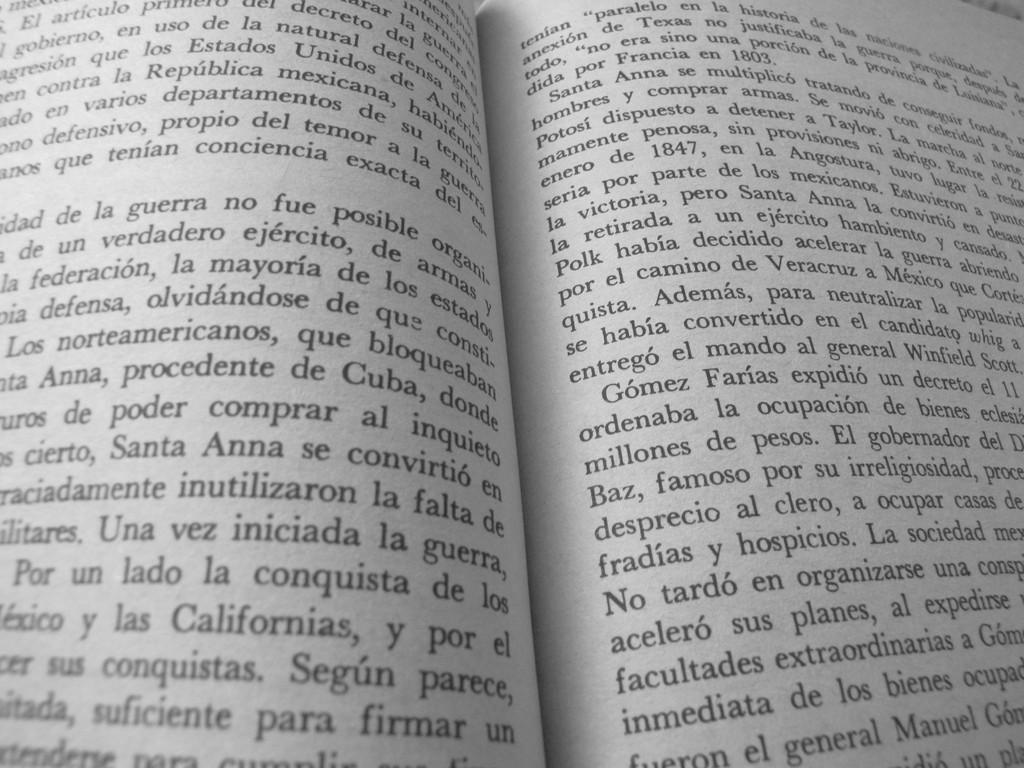<image>
Provide a brief description of the given image. a book in spanish is open to a page talking about las Californias 